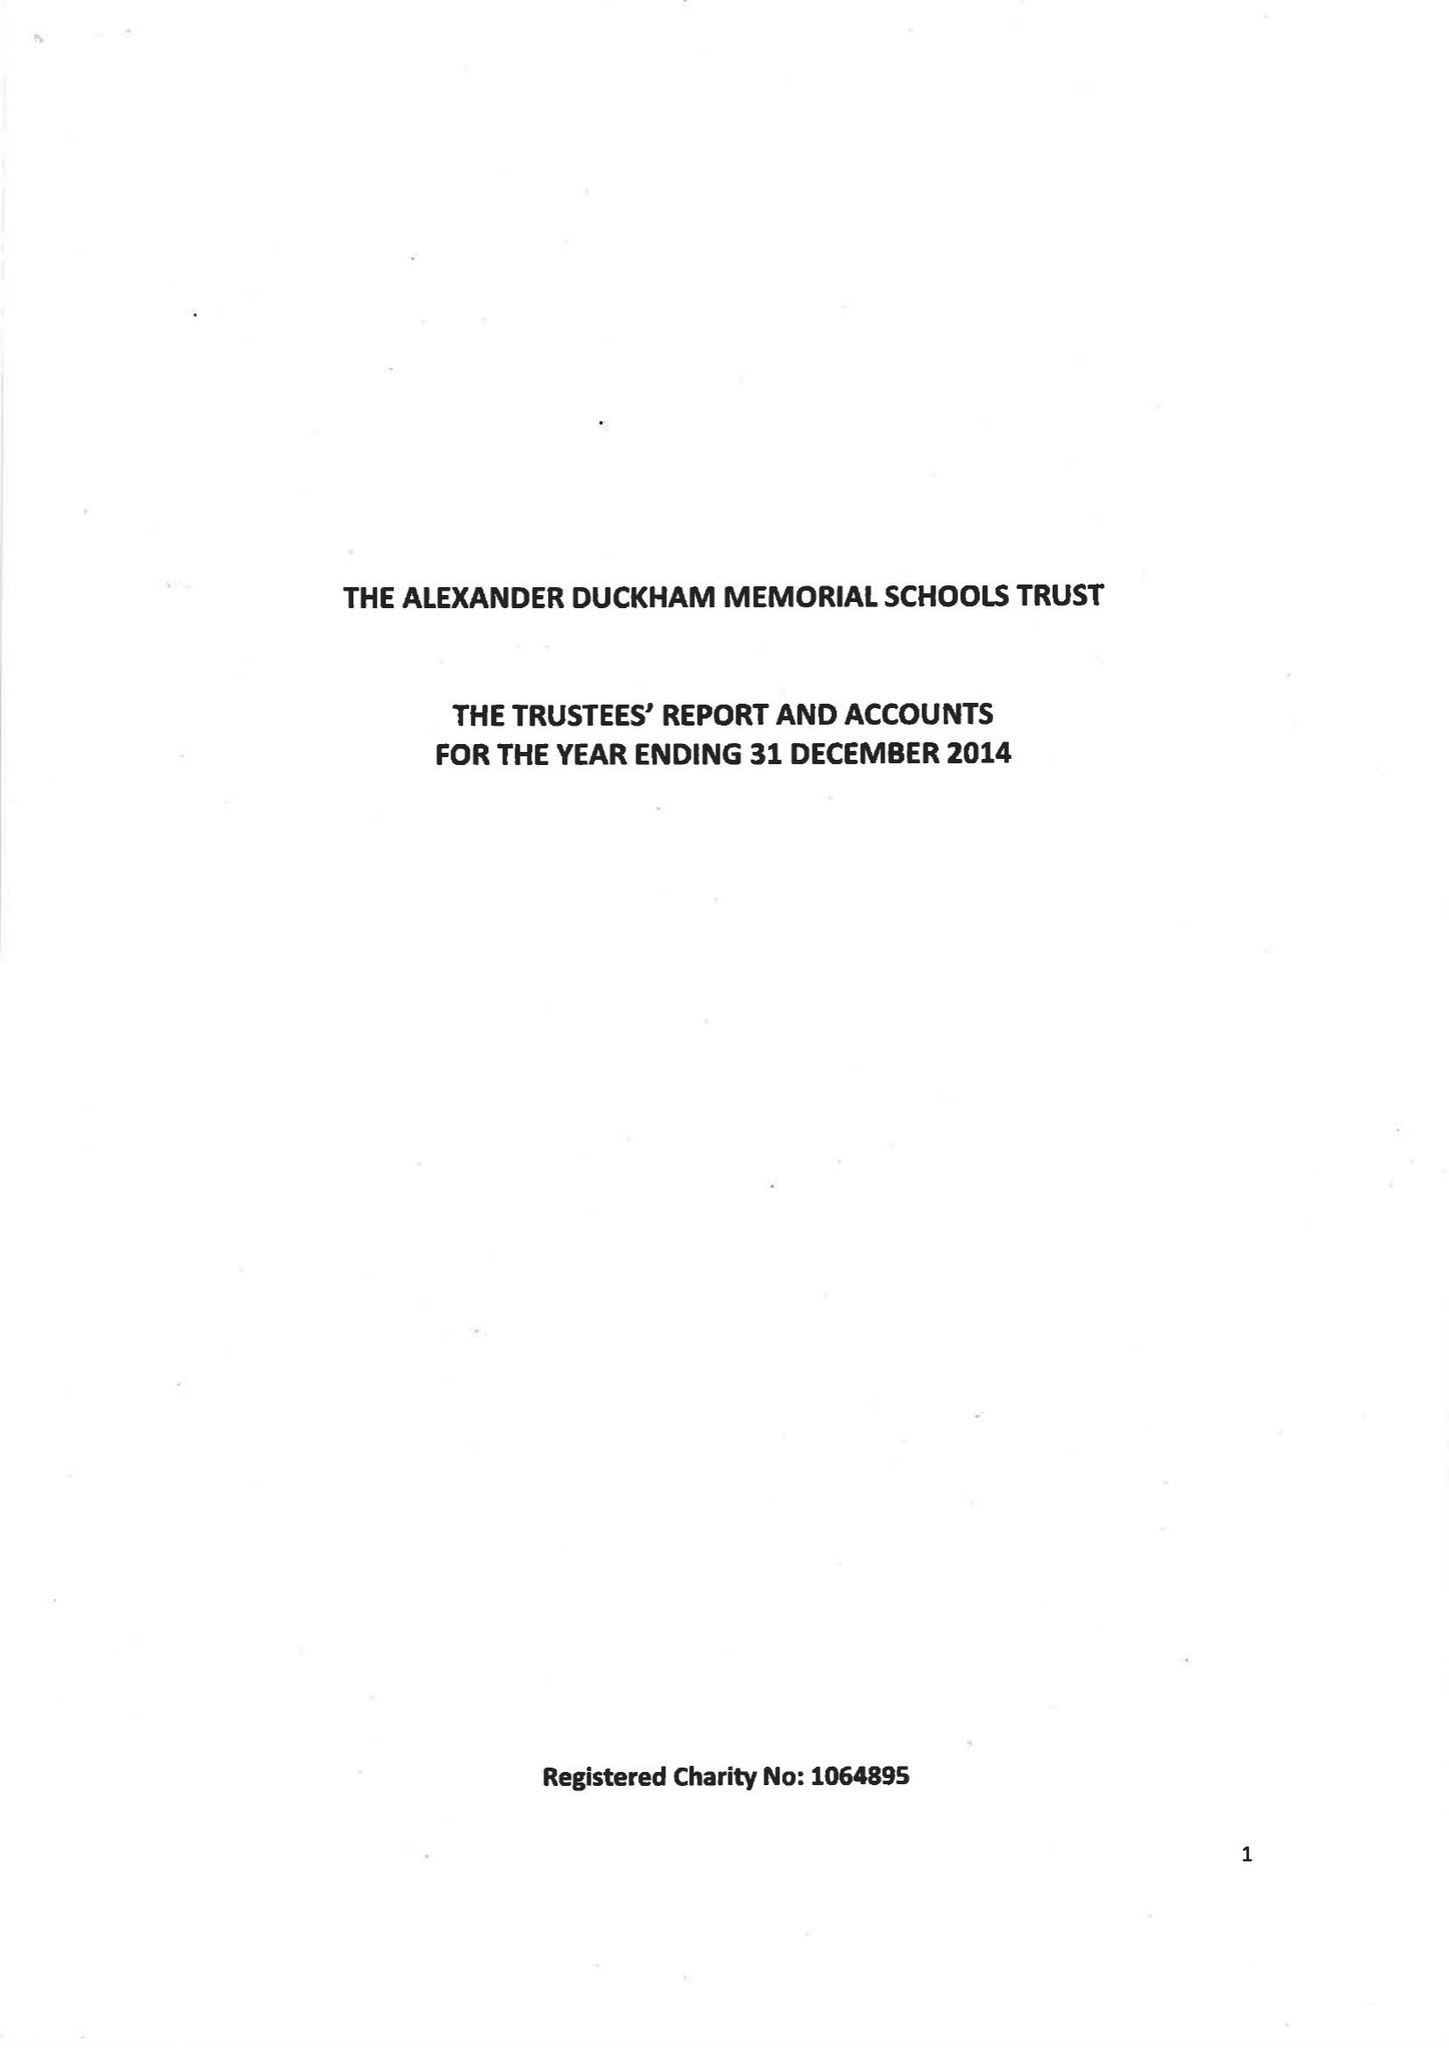What is the value for the income_annually_in_british_pounds?
Answer the question using a single word or phrase. 155588.00 